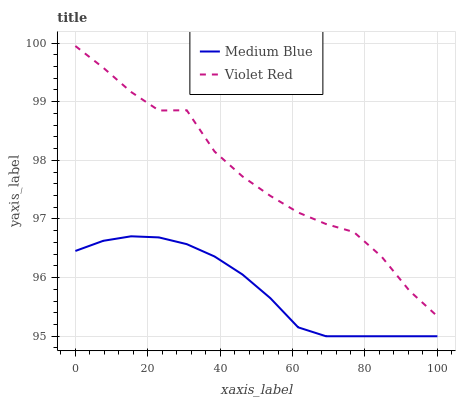Does Medium Blue have the maximum area under the curve?
Answer yes or no. No. Is Medium Blue the roughest?
Answer yes or no. No. Does Medium Blue have the highest value?
Answer yes or no. No. Is Medium Blue less than Violet Red?
Answer yes or no. Yes. Is Violet Red greater than Medium Blue?
Answer yes or no. Yes. Does Medium Blue intersect Violet Red?
Answer yes or no. No. 